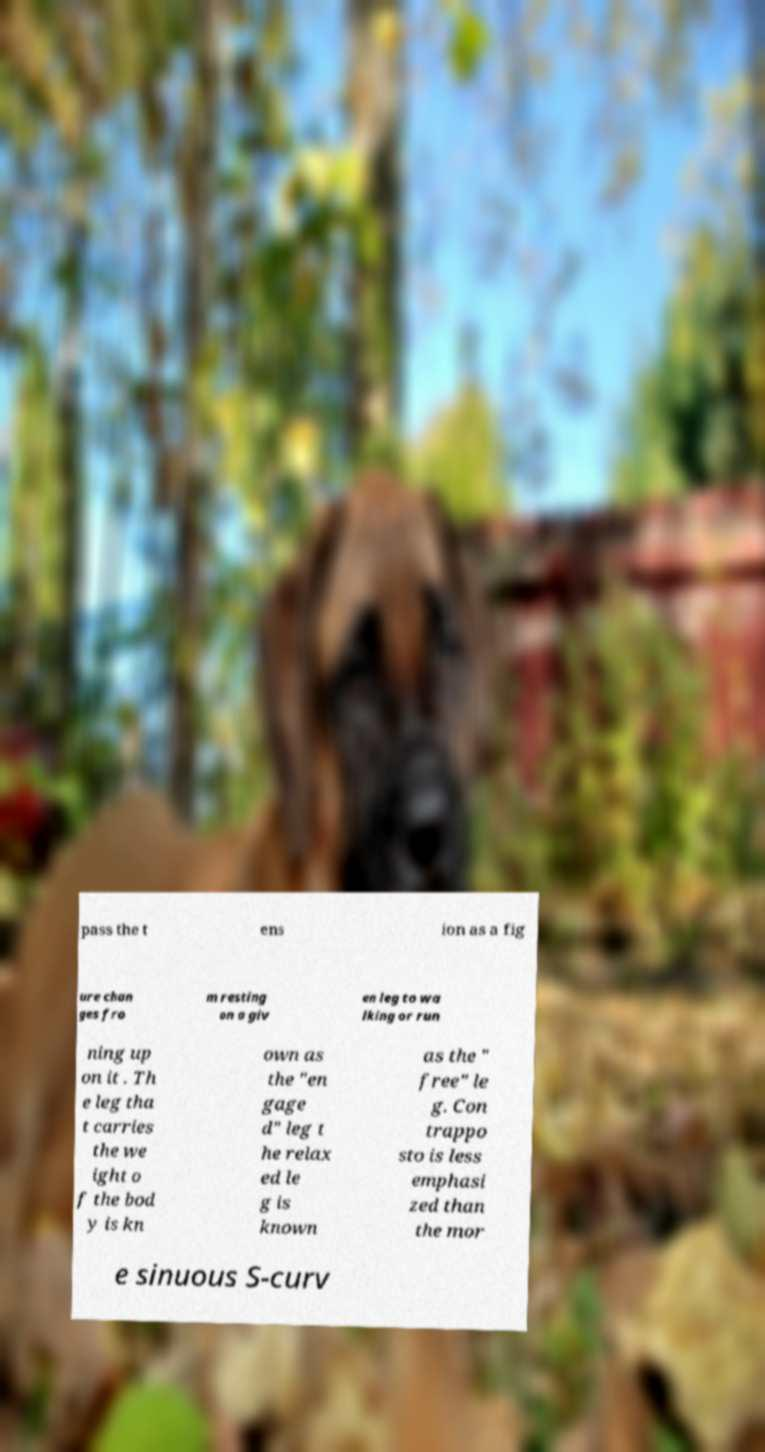Can you accurately transcribe the text from the provided image for me? pass the t ens ion as a fig ure chan ges fro m resting on a giv en leg to wa lking or run ning up on it . Th e leg tha t carries the we ight o f the bod y is kn own as the "en gage d" leg t he relax ed le g is known as the " free" le g. Con trappo sto is less emphasi zed than the mor e sinuous S-curv 